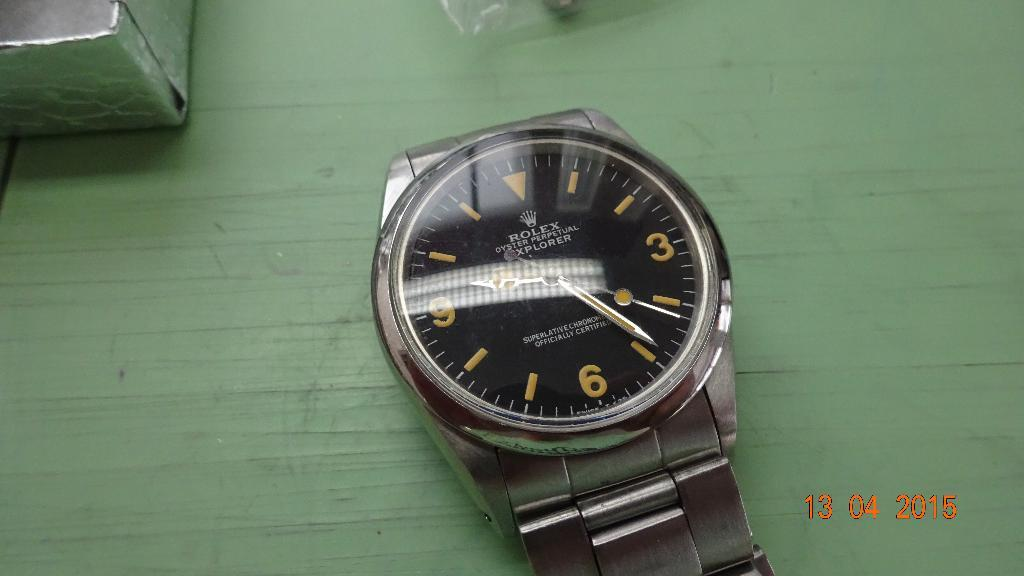Provide a one-sentence caption for the provided image. A silver or stainless watch with"Rolex Oyster Perpetual Explorer" written on it's face on a green wooden background. 